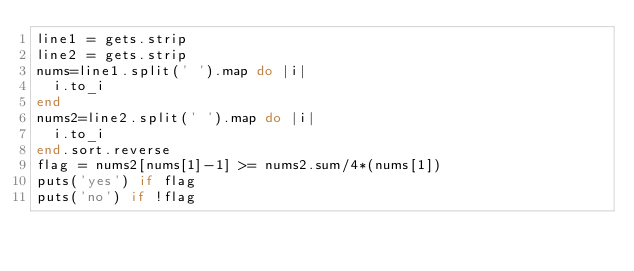<code> <loc_0><loc_0><loc_500><loc_500><_Ruby_>line1 = gets.strip
line2 = gets.strip
nums=line1.split(' ').map do |i|
  i.to_i
end
nums2=line2.split(' ').map do |i|
  i.to_i
end.sort.reverse
flag = nums2[nums[1]-1] >= nums2.sum/4*(nums[1]) 
puts('yes') if flag
puts('no') if !flag</code> 